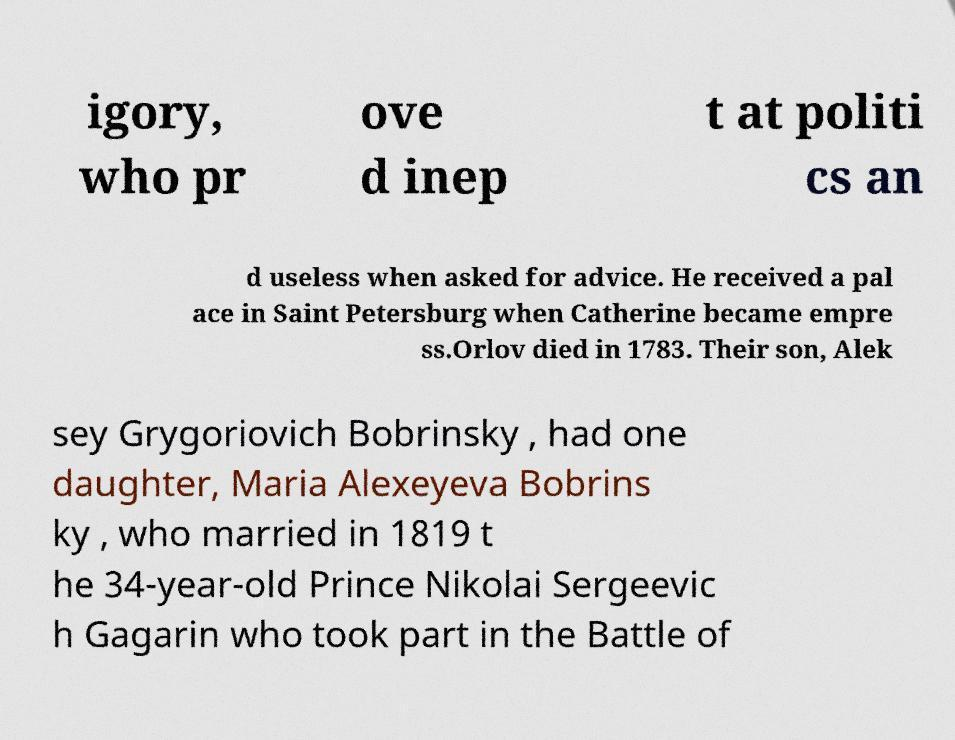Please read and relay the text visible in this image. What does it say? igory, who pr ove d inep t at politi cs an d useless when asked for advice. He received a pal ace in Saint Petersburg when Catherine became empre ss.Orlov died in 1783. Their son, Alek sey Grygoriovich Bobrinsky , had one daughter, Maria Alexeyeva Bobrins ky , who married in 1819 t he 34-year-old Prince Nikolai Sergeevic h Gagarin who took part in the Battle of 